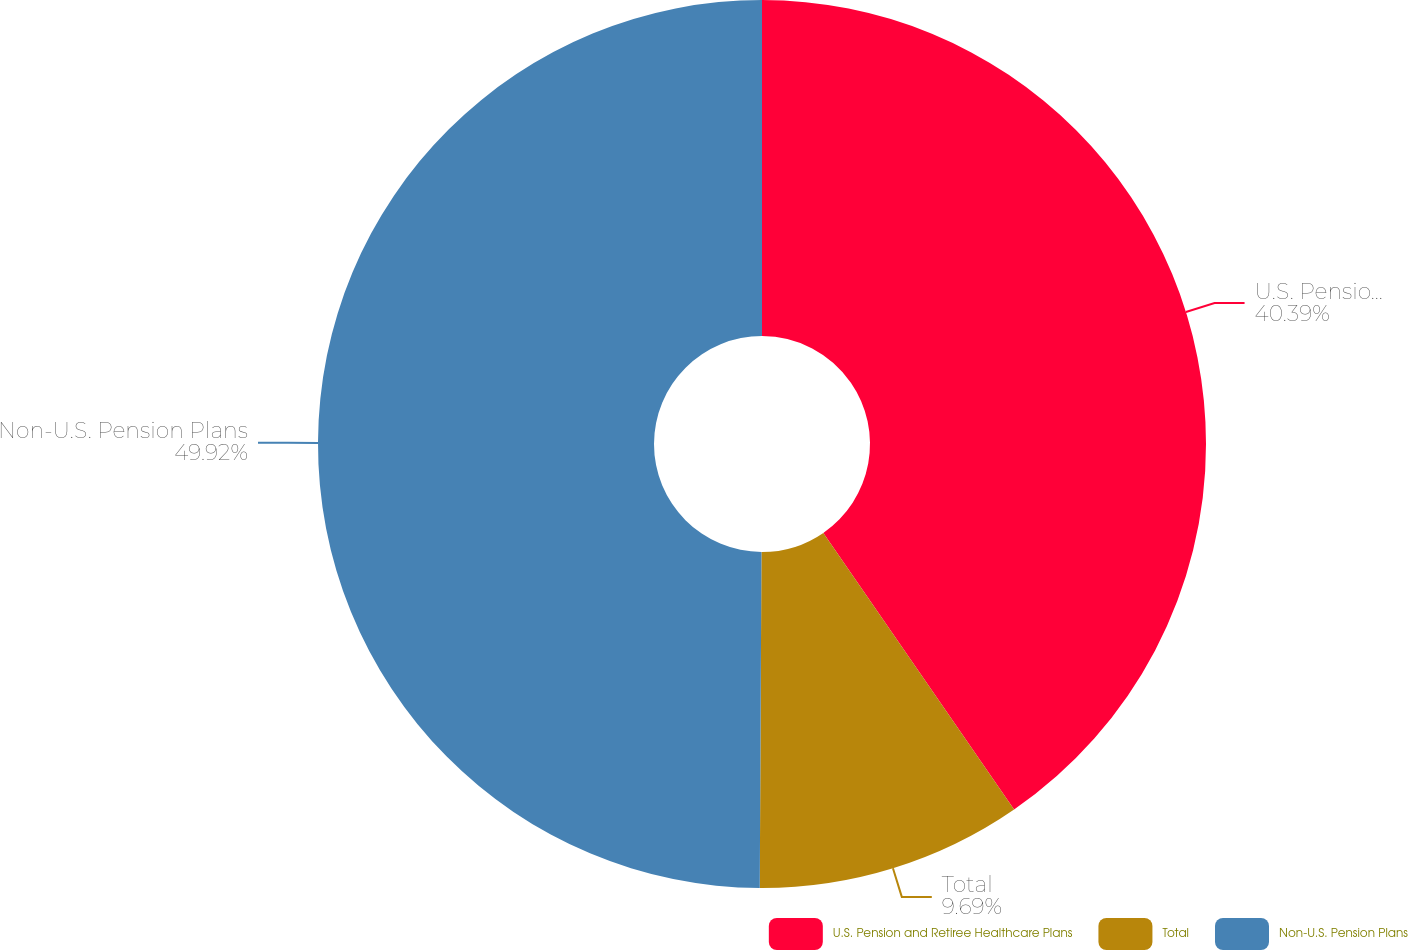Convert chart to OTSL. <chart><loc_0><loc_0><loc_500><loc_500><pie_chart><fcel>U.S. Pension and Retiree Healthcare Plans<fcel>Total<fcel>Non-U.S. Pension Plans<nl><fcel>40.39%<fcel>9.69%<fcel>49.92%<nl></chart> 